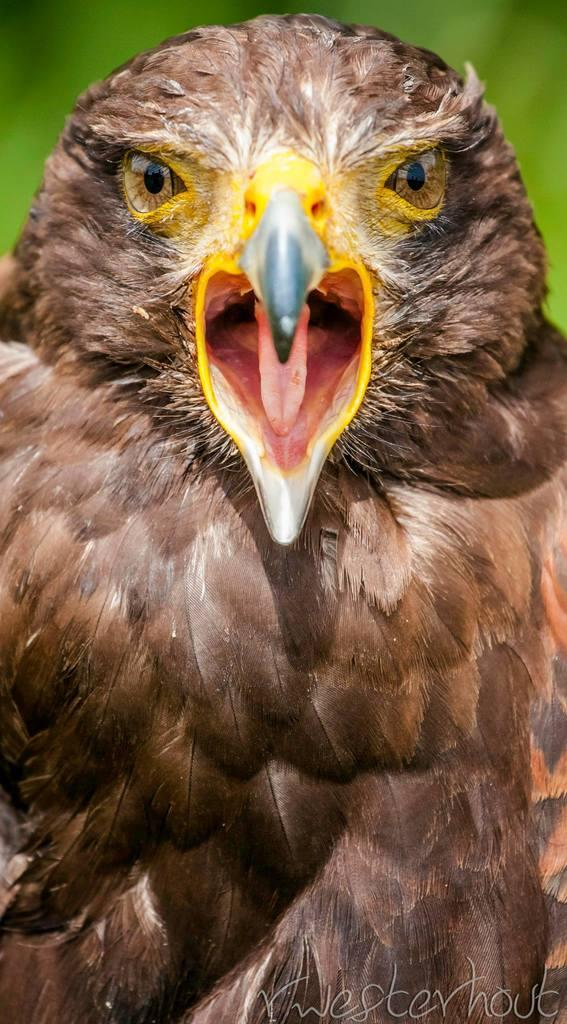What type of animal can be seen in the image? There is a bird in the image. What color is the background at the top of the image? The background at the top of the image is green. What is located at the bottom of the image? There is text at the bottom of the image. Is the bird wearing a crown in the image? There is no crown present in the image, and the bird is not wearing one. What type of home does the bird live in within the image? The image does not show the bird's home, so it cannot be determined from the image. 